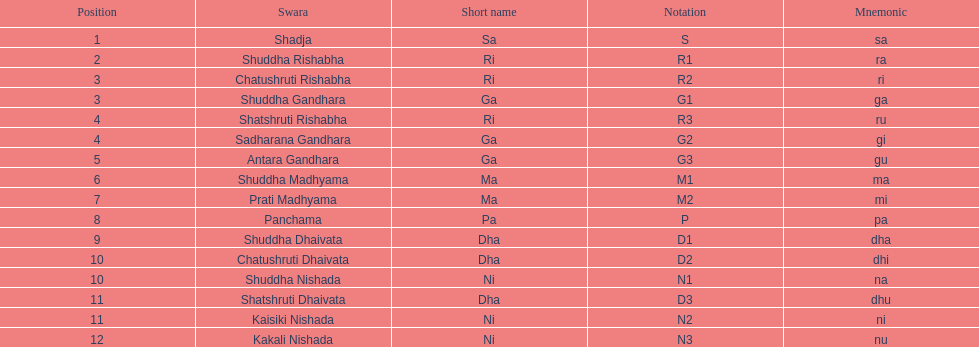What is the overall count of positions mentioned? 16. 